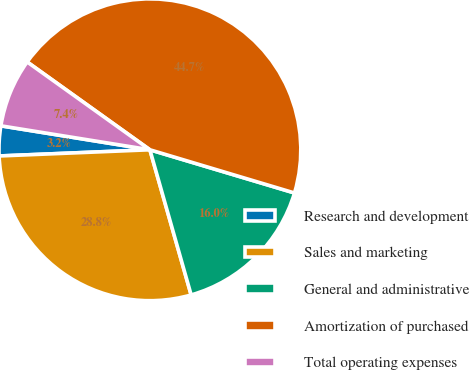<chart> <loc_0><loc_0><loc_500><loc_500><pie_chart><fcel>Research and development<fcel>Sales and marketing<fcel>General and administrative<fcel>Amortization of purchased<fcel>Total operating expenses<nl><fcel>3.19%<fcel>28.75%<fcel>15.97%<fcel>44.73%<fcel>7.35%<nl></chart> 